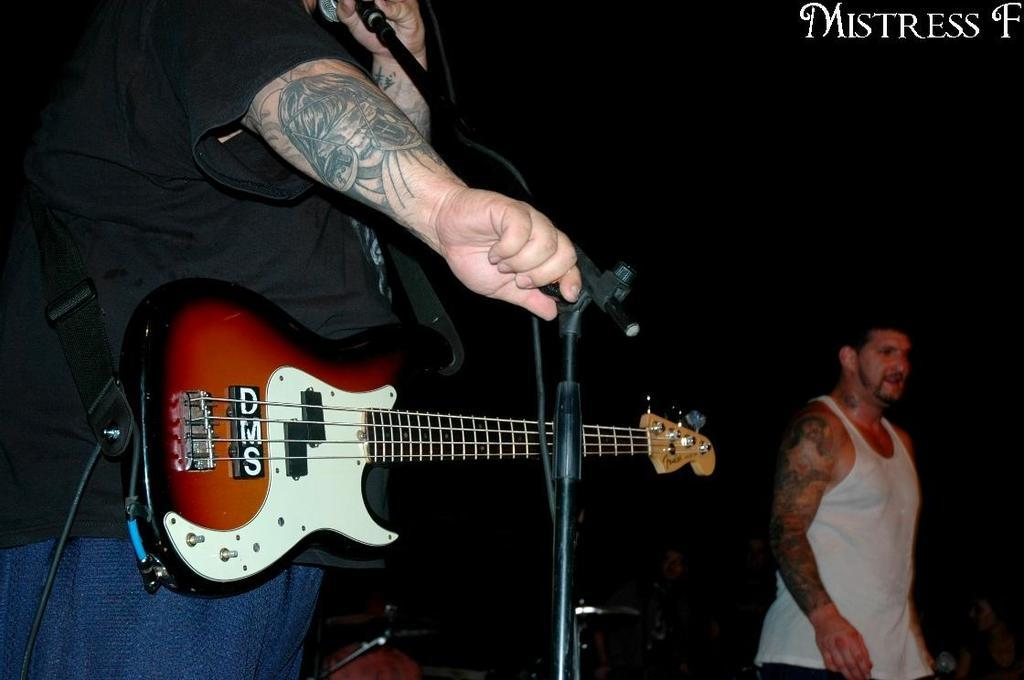How many people are in the image? There are two people in the image. What is one person doing in the image? One person is holding a microphone and talking. What else is the person with the microphone holding? The person with the microphone is also holding a guitar. What type of drug is the rat holding in the image? There is no rat or drug present in the image. What is the spade being used for in the image? There is no spade present in the image. 